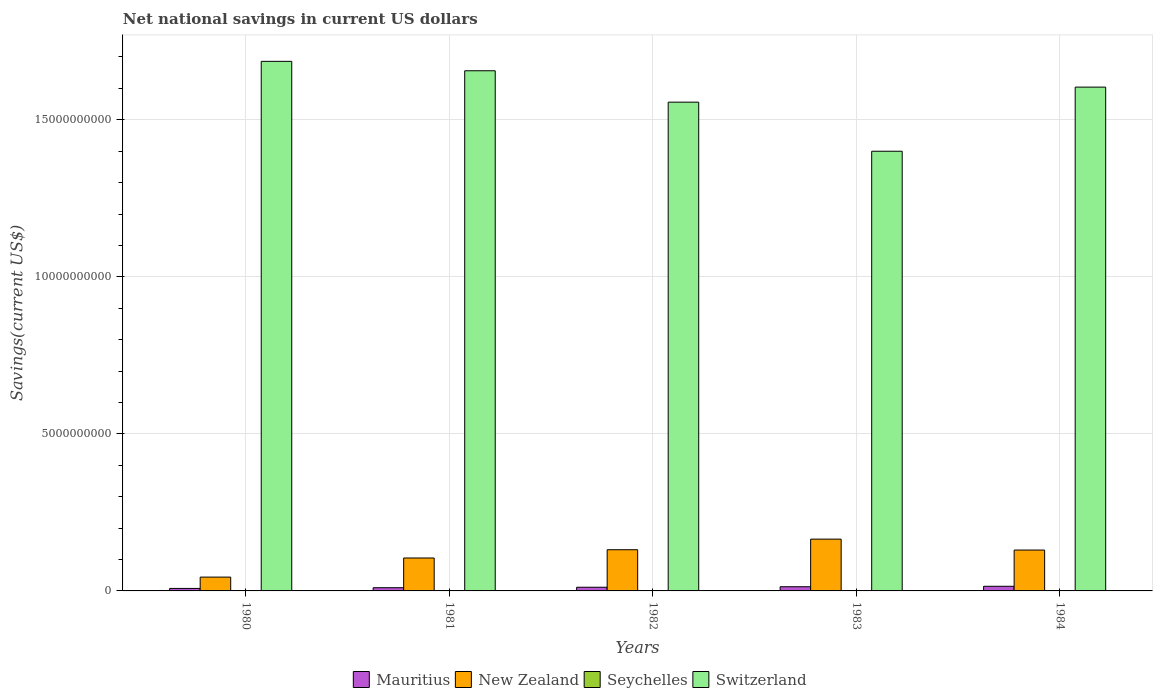How many groups of bars are there?
Make the answer very short. 5. Are the number of bars per tick equal to the number of legend labels?
Offer a very short reply. No. How many bars are there on the 3rd tick from the left?
Your response must be concise. 3. What is the label of the 3rd group of bars from the left?
Your response must be concise. 1982. In how many cases, is the number of bars for a given year not equal to the number of legend labels?
Give a very brief answer. 5. What is the net national savings in Switzerland in 1983?
Ensure brevity in your answer.  1.40e+1. Across all years, what is the maximum net national savings in New Zealand?
Provide a succinct answer. 1.65e+09. Across all years, what is the minimum net national savings in Mauritius?
Provide a short and direct response. 7.94e+07. In which year was the net national savings in Switzerland maximum?
Your answer should be very brief. 1980. What is the total net national savings in Seychelles in the graph?
Give a very brief answer. 0. What is the difference between the net national savings in New Zealand in 1980 and that in 1981?
Offer a very short reply. -6.08e+08. What is the difference between the net national savings in Switzerland in 1982 and the net national savings in Mauritius in 1984?
Keep it short and to the point. 1.54e+1. What is the average net national savings in Mauritius per year?
Give a very brief answer. 1.16e+08. In the year 1983, what is the difference between the net national savings in Mauritius and net national savings in New Zealand?
Provide a succinct answer. -1.52e+09. What is the ratio of the net national savings in Switzerland in 1981 to that in 1982?
Make the answer very short. 1.06. Is the net national savings in New Zealand in 1980 less than that in 1983?
Offer a very short reply. Yes. What is the difference between the highest and the second highest net national savings in Mauritius?
Offer a very short reply. 1.40e+07. What is the difference between the highest and the lowest net national savings in Switzerland?
Make the answer very short. 2.86e+09. In how many years, is the net national savings in Mauritius greater than the average net national savings in Mauritius taken over all years?
Offer a terse response. 3. Is it the case that in every year, the sum of the net national savings in Mauritius and net national savings in New Zealand is greater than the sum of net national savings in Seychelles and net national savings in Switzerland?
Keep it short and to the point. No. Are all the bars in the graph horizontal?
Keep it short and to the point. No. How many years are there in the graph?
Keep it short and to the point. 5. Are the values on the major ticks of Y-axis written in scientific E-notation?
Your answer should be very brief. No. Does the graph contain grids?
Give a very brief answer. Yes. Where does the legend appear in the graph?
Your response must be concise. Bottom center. How many legend labels are there?
Keep it short and to the point. 4. What is the title of the graph?
Make the answer very short. Net national savings in current US dollars. What is the label or title of the X-axis?
Offer a terse response. Years. What is the label or title of the Y-axis?
Offer a terse response. Savings(current US$). What is the Savings(current US$) of Mauritius in 1980?
Make the answer very short. 7.94e+07. What is the Savings(current US$) of New Zealand in 1980?
Keep it short and to the point. 4.40e+08. What is the Savings(current US$) of Seychelles in 1980?
Ensure brevity in your answer.  0. What is the Savings(current US$) in Switzerland in 1980?
Your answer should be very brief. 1.69e+1. What is the Savings(current US$) in Mauritius in 1981?
Give a very brief answer. 1.02e+08. What is the Savings(current US$) of New Zealand in 1981?
Offer a terse response. 1.05e+09. What is the Savings(current US$) of Switzerland in 1981?
Keep it short and to the point. 1.66e+1. What is the Savings(current US$) in Mauritius in 1982?
Your answer should be compact. 1.17e+08. What is the Savings(current US$) of New Zealand in 1982?
Your answer should be compact. 1.31e+09. What is the Savings(current US$) of Switzerland in 1982?
Give a very brief answer. 1.56e+1. What is the Savings(current US$) of Mauritius in 1983?
Provide a short and direct response. 1.33e+08. What is the Savings(current US$) of New Zealand in 1983?
Make the answer very short. 1.65e+09. What is the Savings(current US$) in Switzerland in 1983?
Keep it short and to the point. 1.40e+1. What is the Savings(current US$) in Mauritius in 1984?
Ensure brevity in your answer.  1.47e+08. What is the Savings(current US$) of New Zealand in 1984?
Your answer should be very brief. 1.30e+09. What is the Savings(current US$) in Seychelles in 1984?
Make the answer very short. 0. What is the Savings(current US$) in Switzerland in 1984?
Offer a terse response. 1.60e+1. Across all years, what is the maximum Savings(current US$) in Mauritius?
Offer a terse response. 1.47e+08. Across all years, what is the maximum Savings(current US$) of New Zealand?
Your answer should be compact. 1.65e+09. Across all years, what is the maximum Savings(current US$) in Switzerland?
Give a very brief answer. 1.69e+1. Across all years, what is the minimum Savings(current US$) of Mauritius?
Offer a very short reply. 7.94e+07. Across all years, what is the minimum Savings(current US$) of New Zealand?
Ensure brevity in your answer.  4.40e+08. Across all years, what is the minimum Savings(current US$) of Switzerland?
Your response must be concise. 1.40e+1. What is the total Savings(current US$) of Mauritius in the graph?
Make the answer very short. 5.79e+08. What is the total Savings(current US$) in New Zealand in the graph?
Make the answer very short. 5.75e+09. What is the total Savings(current US$) in Seychelles in the graph?
Your answer should be compact. 0. What is the total Savings(current US$) of Switzerland in the graph?
Your response must be concise. 7.90e+1. What is the difference between the Savings(current US$) in Mauritius in 1980 and that in 1981?
Make the answer very short. -2.27e+07. What is the difference between the Savings(current US$) in New Zealand in 1980 and that in 1981?
Make the answer very short. -6.08e+08. What is the difference between the Savings(current US$) of Switzerland in 1980 and that in 1981?
Ensure brevity in your answer.  2.99e+08. What is the difference between the Savings(current US$) in Mauritius in 1980 and that in 1982?
Ensure brevity in your answer.  -3.78e+07. What is the difference between the Savings(current US$) in New Zealand in 1980 and that in 1982?
Ensure brevity in your answer.  -8.72e+08. What is the difference between the Savings(current US$) of Switzerland in 1980 and that in 1982?
Make the answer very short. 1.30e+09. What is the difference between the Savings(current US$) of Mauritius in 1980 and that in 1983?
Your answer should be compact. -5.39e+07. What is the difference between the Savings(current US$) of New Zealand in 1980 and that in 1983?
Provide a short and direct response. -1.21e+09. What is the difference between the Savings(current US$) of Switzerland in 1980 and that in 1983?
Your answer should be compact. 2.86e+09. What is the difference between the Savings(current US$) of Mauritius in 1980 and that in 1984?
Offer a terse response. -6.79e+07. What is the difference between the Savings(current US$) of New Zealand in 1980 and that in 1984?
Provide a succinct answer. -8.62e+08. What is the difference between the Savings(current US$) of Switzerland in 1980 and that in 1984?
Make the answer very short. 8.20e+08. What is the difference between the Savings(current US$) in Mauritius in 1981 and that in 1982?
Ensure brevity in your answer.  -1.51e+07. What is the difference between the Savings(current US$) in New Zealand in 1981 and that in 1982?
Make the answer very short. -2.63e+08. What is the difference between the Savings(current US$) of Switzerland in 1981 and that in 1982?
Make the answer very short. 1.00e+09. What is the difference between the Savings(current US$) of Mauritius in 1981 and that in 1983?
Ensure brevity in your answer.  -3.12e+07. What is the difference between the Savings(current US$) in New Zealand in 1981 and that in 1983?
Provide a succinct answer. -6.01e+08. What is the difference between the Savings(current US$) of Switzerland in 1981 and that in 1983?
Give a very brief answer. 2.56e+09. What is the difference between the Savings(current US$) of Mauritius in 1981 and that in 1984?
Your response must be concise. -4.52e+07. What is the difference between the Savings(current US$) of New Zealand in 1981 and that in 1984?
Make the answer very short. -2.53e+08. What is the difference between the Savings(current US$) of Switzerland in 1981 and that in 1984?
Your answer should be very brief. 5.21e+08. What is the difference between the Savings(current US$) of Mauritius in 1982 and that in 1983?
Offer a very short reply. -1.61e+07. What is the difference between the Savings(current US$) of New Zealand in 1982 and that in 1983?
Keep it short and to the point. -3.37e+08. What is the difference between the Savings(current US$) in Switzerland in 1982 and that in 1983?
Offer a very short reply. 1.56e+09. What is the difference between the Savings(current US$) of Mauritius in 1982 and that in 1984?
Ensure brevity in your answer.  -3.01e+07. What is the difference between the Savings(current US$) of New Zealand in 1982 and that in 1984?
Your answer should be very brief. 1.02e+07. What is the difference between the Savings(current US$) in Switzerland in 1982 and that in 1984?
Your answer should be compact. -4.79e+08. What is the difference between the Savings(current US$) of Mauritius in 1983 and that in 1984?
Provide a succinct answer. -1.40e+07. What is the difference between the Savings(current US$) of New Zealand in 1983 and that in 1984?
Your answer should be very brief. 3.48e+08. What is the difference between the Savings(current US$) of Switzerland in 1983 and that in 1984?
Offer a very short reply. -2.04e+09. What is the difference between the Savings(current US$) in Mauritius in 1980 and the Savings(current US$) in New Zealand in 1981?
Offer a very short reply. -9.69e+08. What is the difference between the Savings(current US$) in Mauritius in 1980 and the Savings(current US$) in Switzerland in 1981?
Your answer should be compact. -1.65e+1. What is the difference between the Savings(current US$) of New Zealand in 1980 and the Savings(current US$) of Switzerland in 1981?
Give a very brief answer. -1.61e+1. What is the difference between the Savings(current US$) in Mauritius in 1980 and the Savings(current US$) in New Zealand in 1982?
Provide a succinct answer. -1.23e+09. What is the difference between the Savings(current US$) of Mauritius in 1980 and the Savings(current US$) of Switzerland in 1982?
Keep it short and to the point. -1.55e+1. What is the difference between the Savings(current US$) of New Zealand in 1980 and the Savings(current US$) of Switzerland in 1982?
Provide a short and direct response. -1.51e+1. What is the difference between the Savings(current US$) of Mauritius in 1980 and the Savings(current US$) of New Zealand in 1983?
Give a very brief answer. -1.57e+09. What is the difference between the Savings(current US$) in Mauritius in 1980 and the Savings(current US$) in Switzerland in 1983?
Make the answer very short. -1.39e+1. What is the difference between the Savings(current US$) of New Zealand in 1980 and the Savings(current US$) of Switzerland in 1983?
Make the answer very short. -1.36e+1. What is the difference between the Savings(current US$) in Mauritius in 1980 and the Savings(current US$) in New Zealand in 1984?
Offer a terse response. -1.22e+09. What is the difference between the Savings(current US$) of Mauritius in 1980 and the Savings(current US$) of Switzerland in 1984?
Keep it short and to the point. -1.60e+1. What is the difference between the Savings(current US$) of New Zealand in 1980 and the Savings(current US$) of Switzerland in 1984?
Ensure brevity in your answer.  -1.56e+1. What is the difference between the Savings(current US$) of Mauritius in 1981 and the Savings(current US$) of New Zealand in 1982?
Offer a terse response. -1.21e+09. What is the difference between the Savings(current US$) in Mauritius in 1981 and the Savings(current US$) in Switzerland in 1982?
Offer a terse response. -1.55e+1. What is the difference between the Savings(current US$) in New Zealand in 1981 and the Savings(current US$) in Switzerland in 1982?
Offer a terse response. -1.45e+1. What is the difference between the Savings(current US$) in Mauritius in 1981 and the Savings(current US$) in New Zealand in 1983?
Offer a terse response. -1.55e+09. What is the difference between the Savings(current US$) of Mauritius in 1981 and the Savings(current US$) of Switzerland in 1983?
Offer a very short reply. -1.39e+1. What is the difference between the Savings(current US$) of New Zealand in 1981 and the Savings(current US$) of Switzerland in 1983?
Make the answer very short. -1.30e+1. What is the difference between the Savings(current US$) of Mauritius in 1981 and the Savings(current US$) of New Zealand in 1984?
Make the answer very short. -1.20e+09. What is the difference between the Savings(current US$) in Mauritius in 1981 and the Savings(current US$) in Switzerland in 1984?
Offer a terse response. -1.59e+1. What is the difference between the Savings(current US$) of New Zealand in 1981 and the Savings(current US$) of Switzerland in 1984?
Offer a terse response. -1.50e+1. What is the difference between the Savings(current US$) in Mauritius in 1982 and the Savings(current US$) in New Zealand in 1983?
Ensure brevity in your answer.  -1.53e+09. What is the difference between the Savings(current US$) of Mauritius in 1982 and the Savings(current US$) of Switzerland in 1983?
Your response must be concise. -1.39e+1. What is the difference between the Savings(current US$) of New Zealand in 1982 and the Savings(current US$) of Switzerland in 1983?
Provide a short and direct response. -1.27e+1. What is the difference between the Savings(current US$) in Mauritius in 1982 and the Savings(current US$) in New Zealand in 1984?
Keep it short and to the point. -1.18e+09. What is the difference between the Savings(current US$) in Mauritius in 1982 and the Savings(current US$) in Switzerland in 1984?
Make the answer very short. -1.59e+1. What is the difference between the Savings(current US$) of New Zealand in 1982 and the Savings(current US$) of Switzerland in 1984?
Give a very brief answer. -1.47e+1. What is the difference between the Savings(current US$) of Mauritius in 1983 and the Savings(current US$) of New Zealand in 1984?
Your answer should be compact. -1.17e+09. What is the difference between the Savings(current US$) of Mauritius in 1983 and the Savings(current US$) of Switzerland in 1984?
Your answer should be very brief. -1.59e+1. What is the difference between the Savings(current US$) of New Zealand in 1983 and the Savings(current US$) of Switzerland in 1984?
Offer a very short reply. -1.44e+1. What is the average Savings(current US$) in Mauritius per year?
Your answer should be very brief. 1.16e+08. What is the average Savings(current US$) in New Zealand per year?
Provide a short and direct response. 1.15e+09. What is the average Savings(current US$) in Switzerland per year?
Your response must be concise. 1.58e+1. In the year 1980, what is the difference between the Savings(current US$) of Mauritius and Savings(current US$) of New Zealand?
Keep it short and to the point. -3.60e+08. In the year 1980, what is the difference between the Savings(current US$) of Mauritius and Savings(current US$) of Switzerland?
Your answer should be compact. -1.68e+1. In the year 1980, what is the difference between the Savings(current US$) of New Zealand and Savings(current US$) of Switzerland?
Ensure brevity in your answer.  -1.64e+1. In the year 1981, what is the difference between the Savings(current US$) in Mauritius and Savings(current US$) in New Zealand?
Your response must be concise. -9.46e+08. In the year 1981, what is the difference between the Savings(current US$) of Mauritius and Savings(current US$) of Switzerland?
Make the answer very short. -1.65e+1. In the year 1981, what is the difference between the Savings(current US$) in New Zealand and Savings(current US$) in Switzerland?
Your answer should be compact. -1.55e+1. In the year 1982, what is the difference between the Savings(current US$) in Mauritius and Savings(current US$) in New Zealand?
Ensure brevity in your answer.  -1.19e+09. In the year 1982, what is the difference between the Savings(current US$) in Mauritius and Savings(current US$) in Switzerland?
Your response must be concise. -1.54e+1. In the year 1982, what is the difference between the Savings(current US$) of New Zealand and Savings(current US$) of Switzerland?
Offer a very short reply. -1.42e+1. In the year 1983, what is the difference between the Savings(current US$) of Mauritius and Savings(current US$) of New Zealand?
Provide a succinct answer. -1.52e+09. In the year 1983, what is the difference between the Savings(current US$) of Mauritius and Savings(current US$) of Switzerland?
Make the answer very short. -1.39e+1. In the year 1983, what is the difference between the Savings(current US$) in New Zealand and Savings(current US$) in Switzerland?
Your response must be concise. -1.23e+1. In the year 1984, what is the difference between the Savings(current US$) of Mauritius and Savings(current US$) of New Zealand?
Your answer should be compact. -1.15e+09. In the year 1984, what is the difference between the Savings(current US$) of Mauritius and Savings(current US$) of Switzerland?
Your response must be concise. -1.59e+1. In the year 1984, what is the difference between the Savings(current US$) in New Zealand and Savings(current US$) in Switzerland?
Make the answer very short. -1.47e+1. What is the ratio of the Savings(current US$) in Mauritius in 1980 to that in 1981?
Keep it short and to the point. 0.78. What is the ratio of the Savings(current US$) in New Zealand in 1980 to that in 1981?
Your answer should be compact. 0.42. What is the ratio of the Savings(current US$) in Switzerland in 1980 to that in 1981?
Give a very brief answer. 1.02. What is the ratio of the Savings(current US$) in Mauritius in 1980 to that in 1982?
Make the answer very short. 0.68. What is the ratio of the Savings(current US$) in New Zealand in 1980 to that in 1982?
Your response must be concise. 0.34. What is the ratio of the Savings(current US$) of Switzerland in 1980 to that in 1982?
Offer a very short reply. 1.08. What is the ratio of the Savings(current US$) of Mauritius in 1980 to that in 1983?
Offer a very short reply. 0.6. What is the ratio of the Savings(current US$) in New Zealand in 1980 to that in 1983?
Keep it short and to the point. 0.27. What is the ratio of the Savings(current US$) of Switzerland in 1980 to that in 1983?
Provide a succinct answer. 1.2. What is the ratio of the Savings(current US$) of Mauritius in 1980 to that in 1984?
Your answer should be compact. 0.54. What is the ratio of the Savings(current US$) of New Zealand in 1980 to that in 1984?
Give a very brief answer. 0.34. What is the ratio of the Savings(current US$) in Switzerland in 1980 to that in 1984?
Offer a very short reply. 1.05. What is the ratio of the Savings(current US$) of Mauritius in 1981 to that in 1982?
Give a very brief answer. 0.87. What is the ratio of the Savings(current US$) in New Zealand in 1981 to that in 1982?
Offer a very short reply. 0.8. What is the ratio of the Savings(current US$) of Switzerland in 1981 to that in 1982?
Make the answer very short. 1.06. What is the ratio of the Savings(current US$) of Mauritius in 1981 to that in 1983?
Your answer should be compact. 0.77. What is the ratio of the Savings(current US$) of New Zealand in 1981 to that in 1983?
Provide a short and direct response. 0.64. What is the ratio of the Savings(current US$) of Switzerland in 1981 to that in 1983?
Provide a short and direct response. 1.18. What is the ratio of the Savings(current US$) of Mauritius in 1981 to that in 1984?
Keep it short and to the point. 0.69. What is the ratio of the Savings(current US$) in New Zealand in 1981 to that in 1984?
Offer a very short reply. 0.81. What is the ratio of the Savings(current US$) of Switzerland in 1981 to that in 1984?
Provide a short and direct response. 1.03. What is the ratio of the Savings(current US$) of Mauritius in 1982 to that in 1983?
Provide a succinct answer. 0.88. What is the ratio of the Savings(current US$) in New Zealand in 1982 to that in 1983?
Offer a terse response. 0.8. What is the ratio of the Savings(current US$) in Switzerland in 1982 to that in 1983?
Provide a succinct answer. 1.11. What is the ratio of the Savings(current US$) of Mauritius in 1982 to that in 1984?
Keep it short and to the point. 0.8. What is the ratio of the Savings(current US$) in New Zealand in 1982 to that in 1984?
Your answer should be compact. 1.01. What is the ratio of the Savings(current US$) in Switzerland in 1982 to that in 1984?
Your response must be concise. 0.97. What is the ratio of the Savings(current US$) of Mauritius in 1983 to that in 1984?
Your response must be concise. 0.9. What is the ratio of the Savings(current US$) of New Zealand in 1983 to that in 1984?
Ensure brevity in your answer.  1.27. What is the ratio of the Savings(current US$) of Switzerland in 1983 to that in 1984?
Your response must be concise. 0.87. What is the difference between the highest and the second highest Savings(current US$) of Mauritius?
Give a very brief answer. 1.40e+07. What is the difference between the highest and the second highest Savings(current US$) of New Zealand?
Your answer should be very brief. 3.37e+08. What is the difference between the highest and the second highest Savings(current US$) of Switzerland?
Ensure brevity in your answer.  2.99e+08. What is the difference between the highest and the lowest Savings(current US$) of Mauritius?
Offer a very short reply. 6.79e+07. What is the difference between the highest and the lowest Savings(current US$) of New Zealand?
Provide a succinct answer. 1.21e+09. What is the difference between the highest and the lowest Savings(current US$) in Switzerland?
Give a very brief answer. 2.86e+09. 